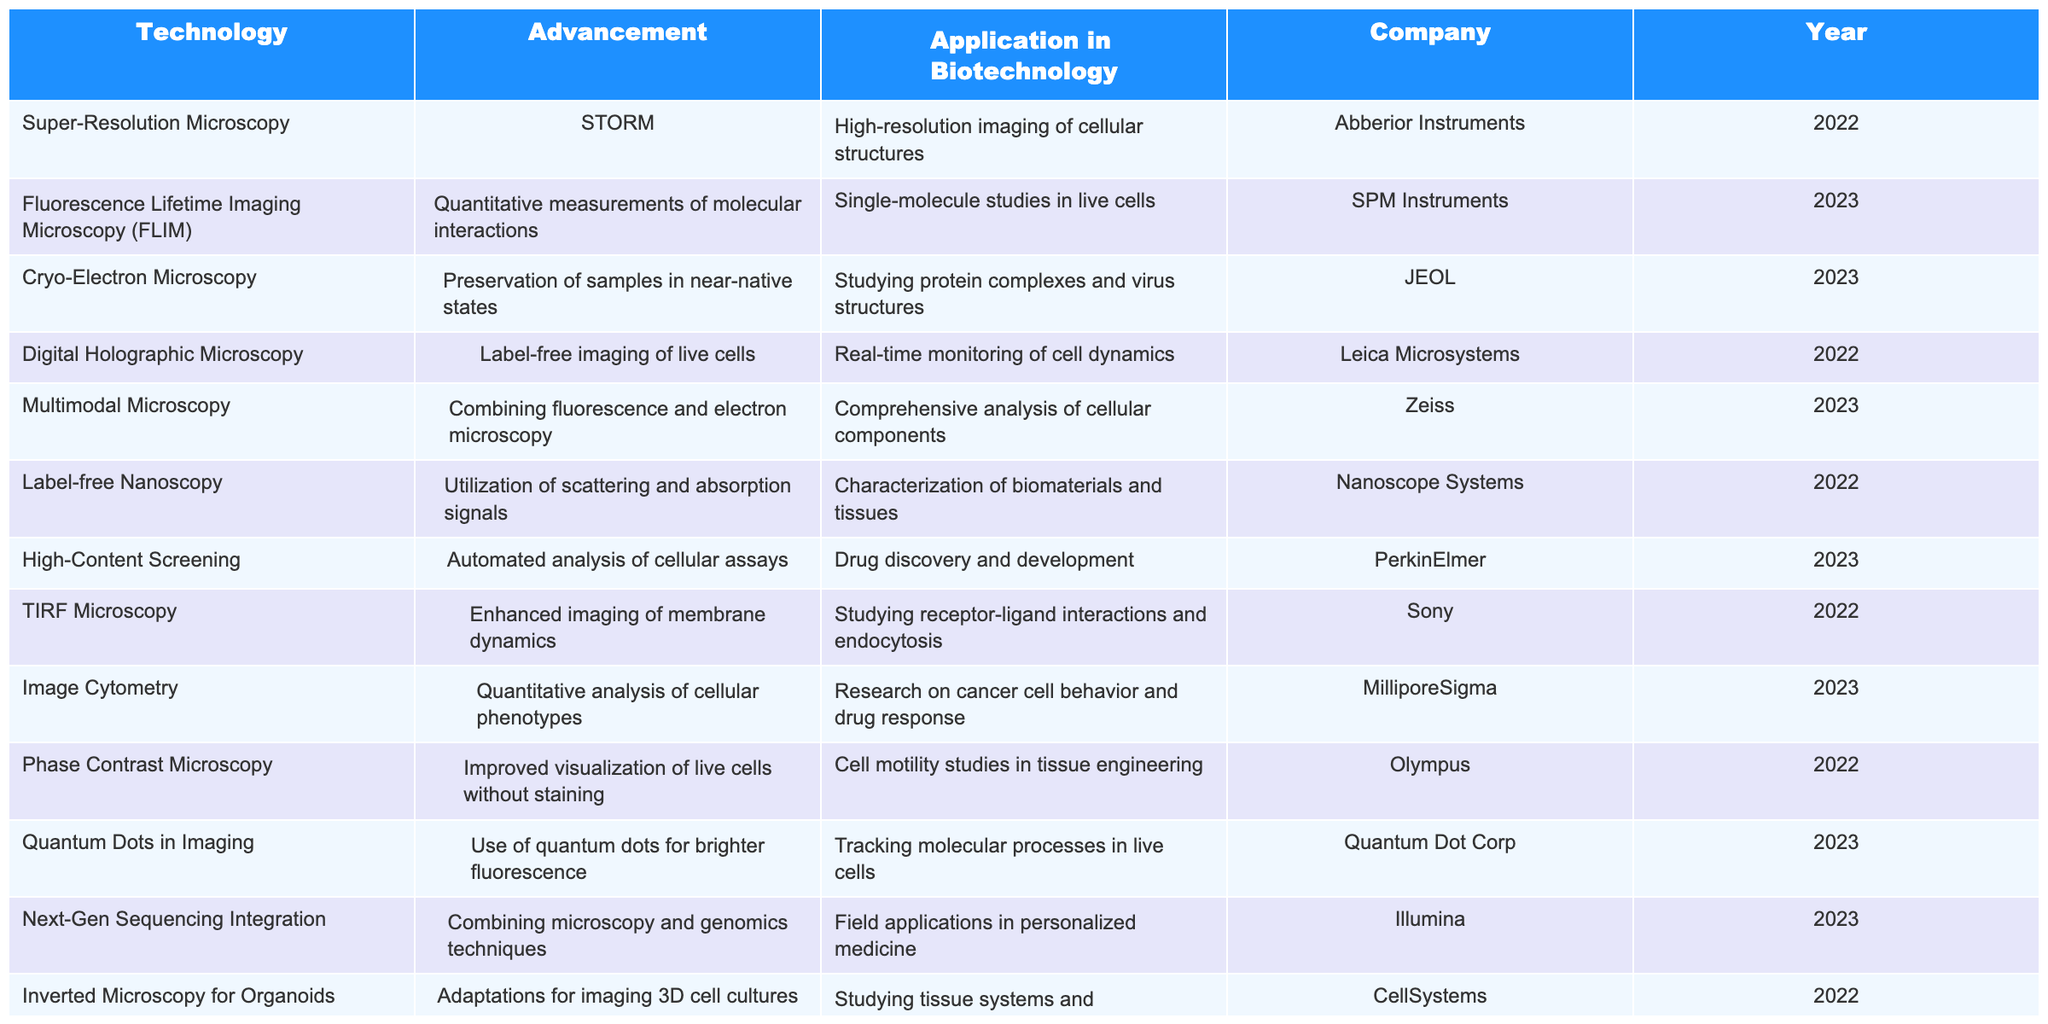What technology was developed by Abberior Instruments in 2022? By looking at the table, I can identify that Abberior Instruments is associated with the Super-Resolution Microscopy technology, and it mentions the advancement STORM was made in 2022.
Answer: Super-Resolution Microscopy Which application is associated with High-Content Screening? The application listed in the table for High-Content Screening, developed in 2023 by PerkinElmer, is drug discovery and development.
Answer: Drug discovery and development How many companies introduced new microscopy technologies in 2023? By checking the table, I can count the number of unique companies that introduced advancements in 2023, which includes SPM Instruments, JEOL, Zeiss, PerkinElmer, Quantum Dot Corp, Illumina, and Adaptive Optics Associates, totaling to seven.
Answer: 7 Which microscopy technology focuses on the study of protein complexes and virus structures? The table specifies that Cryo-Electron Microscopy is used for studying protein complexes and virus structures, and this advancement was made by JEOL in 2023.
Answer: Cryo-Electron Microscopy What is the primary application of Phase Contrast Microscopy according to the table? Upon examining the table, Phase Contrast Microscopy is indicated to improve visualization of live cells without staining, particularly for cell motility studies in tissue engineering.
Answer: Cell motility studies in tissue engineering Which technologies were developed by companies that also offered their advancements in 2022? To answer this, I can look at the table and find that both Digital Holographic Microscopy and Label-free Nanoscopy were developed by different companies in 2022. Hence, the technologies would be Digital Holographic Microscopy and Label-free Nanoscopy.
Answer: Digital Holographic Microscopy, Label-free Nanoscopy Is there a microscopy advancement that integrates next-generation sequencing? Yes, the table indicates that Next-Gen Sequencing Integration combines microscopy and genomics techniques, developed by Illumina in 2023.
Answer: Yes What is the difference in year of advancement between Light Sheet Fluorescence Microscopy and Fluorescence Lifetime Imaging Microscopy? I find that Light Sheet Fluorescence Microscopy was introduced in 2022, and Fluorescence Lifetime Imaging Microscopy was introduced in 2023. Therefore, the difference in years is 2023 - 2022 = 1 year.
Answer: 1 year Name two microscopy technologies that utilize label-free techniques. Looking at the table, Digital Holographic Microscopy and Label-free Nanoscopy both employ label-free methods, as indicated in their descriptions.
Answer: Digital Holographic Microscopy, Label-free Nanoscopy Which company's technology allows for enhanced imaging of membrane dynamics? According to the table, Sony developed TIRF Microscopy, which is associated with enhanced imaging of membrane dynamics in 2022.
Answer: Sony What percentage of the listed advancements focus on live cell imaging? To find the percentage, I will identify all advancements related to live cell imaging — these include Digital Holographic Microscopy, Fluorescence Lifetime Imaging Microscopy, TIRF Microscopy, and Light Sheet Fluorescence Microscopy — totaling four. There are 14 total advancements, so the percentage is (4/14) * 100 = approximately 28.57%.
Answer: Approximately 28.57% 